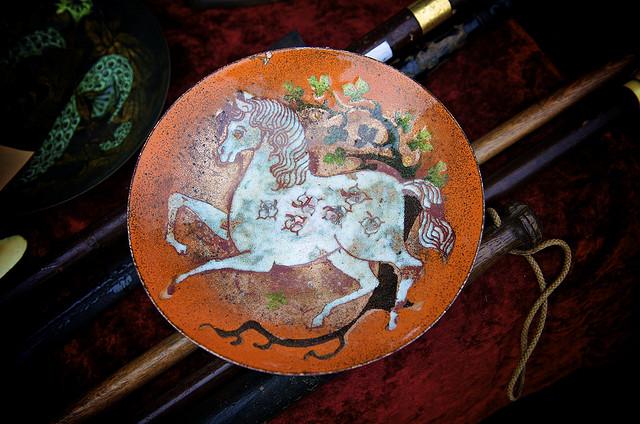How many legs are painted white?
Short answer required. 4. How many wooden sticks are there?
Quick response, please. 5. How many cherry blossoms adorn the horse?
Keep it brief. 6. 